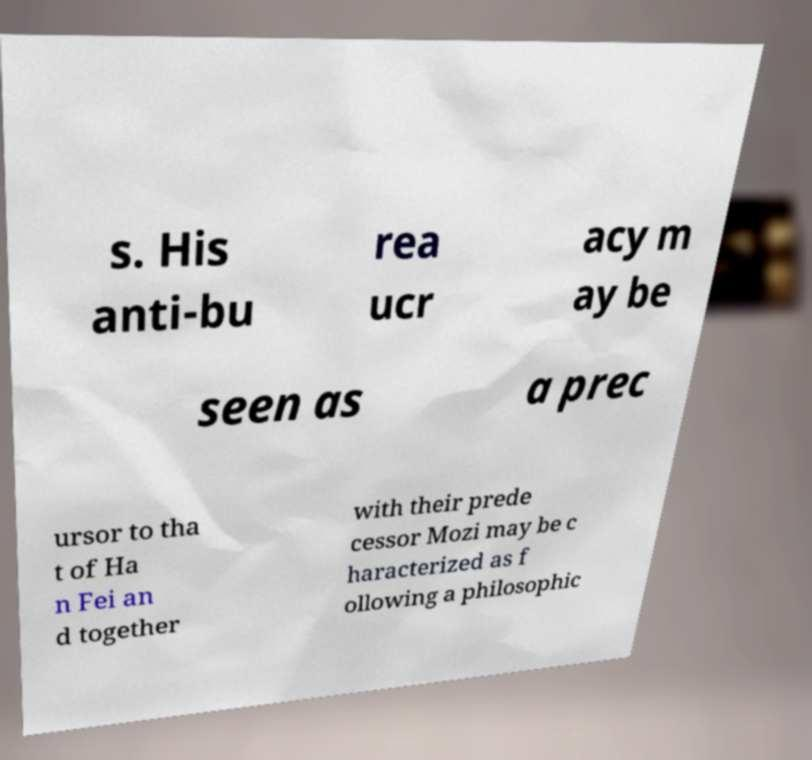Please read and relay the text visible in this image. What does it say? s. His anti-bu rea ucr acy m ay be seen as a prec ursor to tha t of Ha n Fei an d together with their prede cessor Mozi may be c haracterized as f ollowing a philosophic 